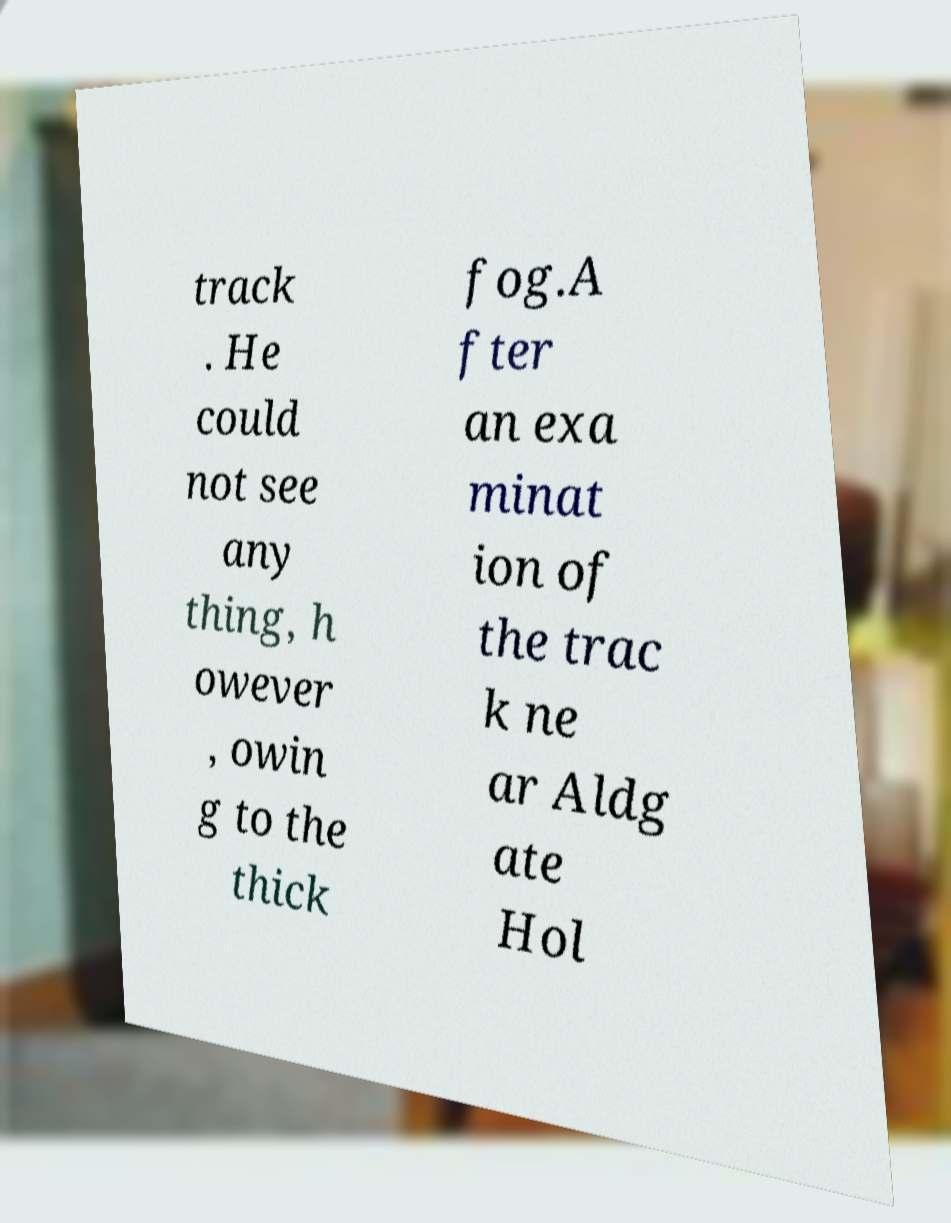For documentation purposes, I need the text within this image transcribed. Could you provide that? track . He could not see any thing, h owever , owin g to the thick fog.A fter an exa minat ion of the trac k ne ar Aldg ate Hol 